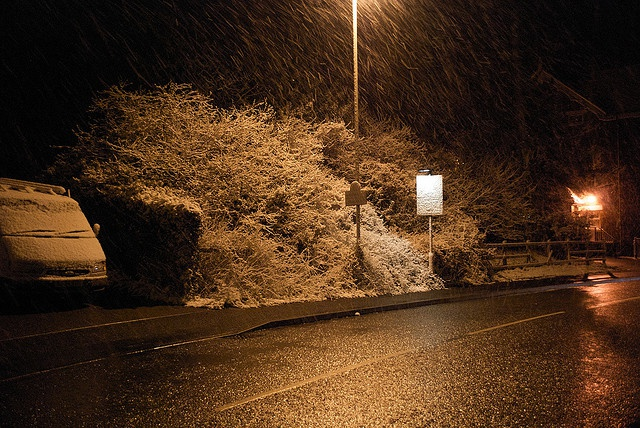Describe the objects in this image and their specific colors. I can see a car in black, brown, and maroon tones in this image. 